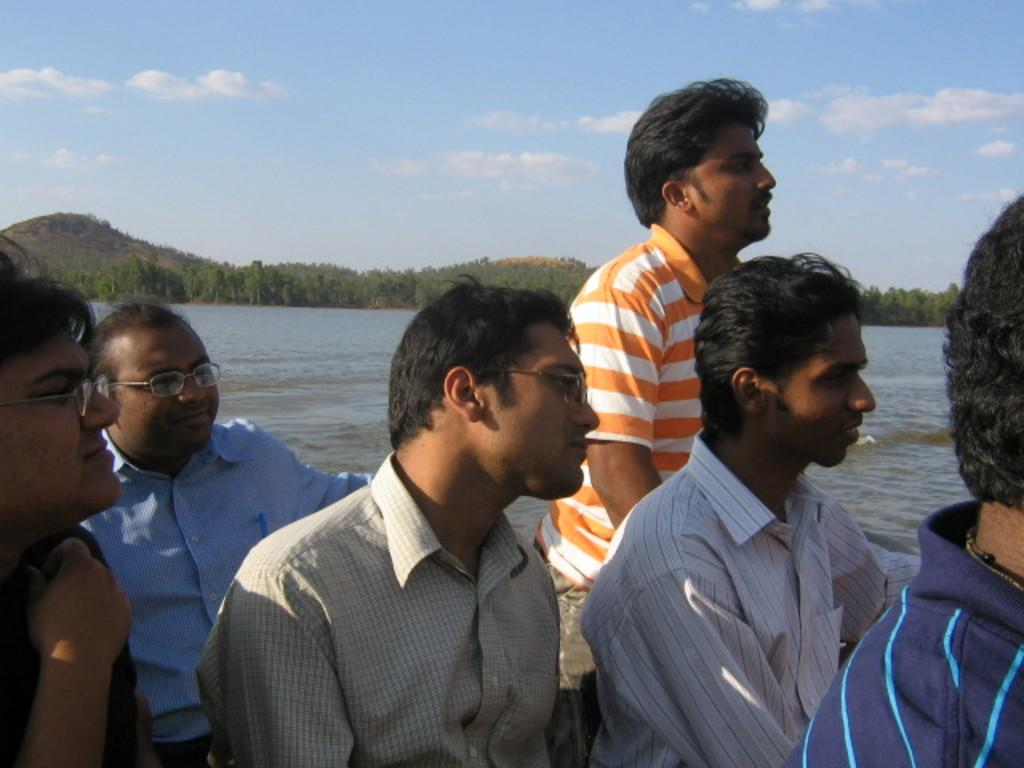What are the people in the image doing? The people in the image are sitting. What direction are the people looking in the image? The people are looking to the right side of the image. What can be seen in the background of the image? There are trees, mountains, and the sky visible in the background of the image. What type of heart-shaped pump can be seen in the image? There is no heart-shaped pump present in the image. 